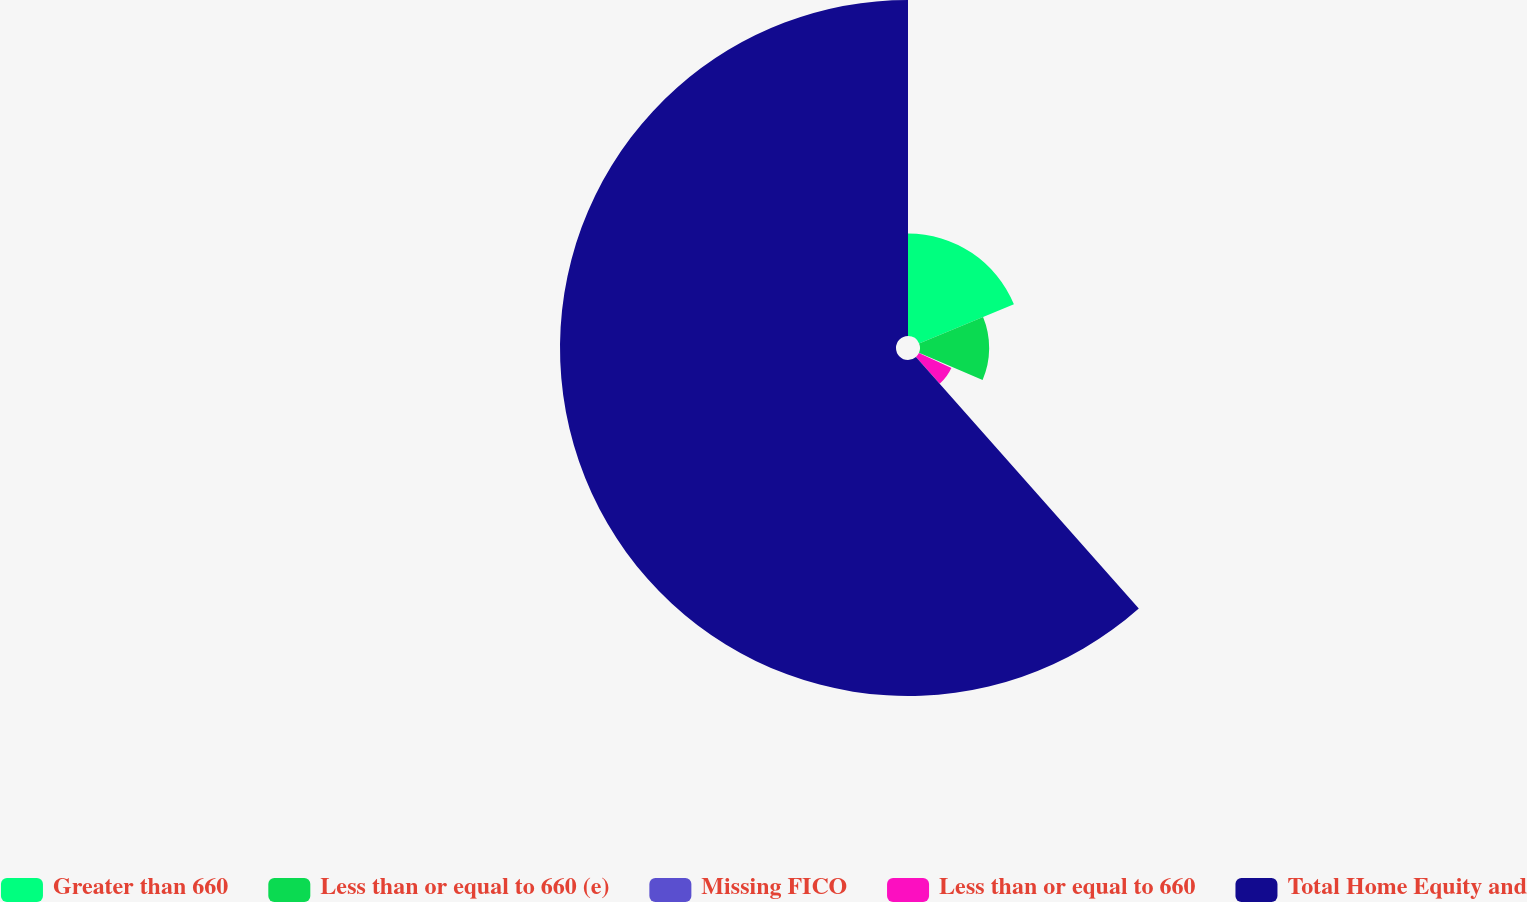Convert chart to OTSL. <chart><loc_0><loc_0><loc_500><loc_500><pie_chart><fcel>Greater than 660<fcel>Less than or equal to 660 (e)<fcel>Missing FICO<fcel>Less than or equal to 660<fcel>Total Home Equity and<nl><fcel>18.78%<fcel>12.67%<fcel>0.45%<fcel>6.56%<fcel>61.54%<nl></chart> 